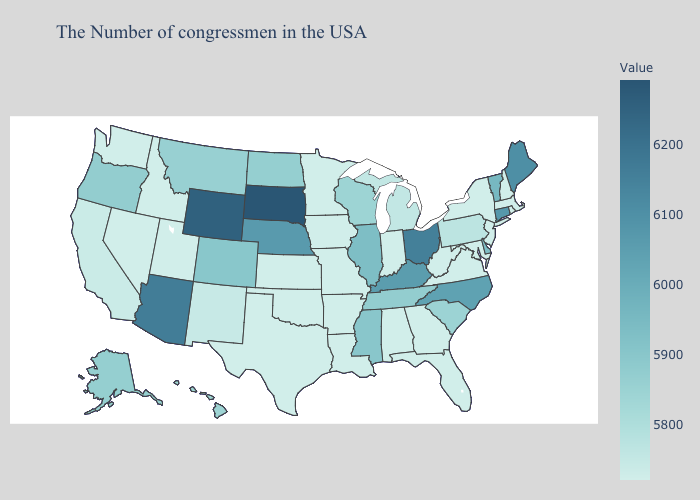Does Nebraska have a lower value than Wisconsin?
Keep it brief. No. Which states have the lowest value in the Northeast?
Concise answer only. Massachusetts, Rhode Island, New Hampshire, New York, New Jersey. Does South Dakota have the highest value in the USA?
Give a very brief answer. Yes. Is the legend a continuous bar?
Keep it brief. Yes. Does South Dakota have the highest value in the USA?
Quick response, please. Yes. Does South Carolina have the lowest value in the USA?
Write a very short answer. No. Is the legend a continuous bar?
Be succinct. Yes. Which states have the highest value in the USA?
Write a very short answer. South Dakota. Is the legend a continuous bar?
Be succinct. Yes. Among the states that border Montana , which have the highest value?
Keep it brief. South Dakota. Among the states that border Alabama , does Florida have the lowest value?
Give a very brief answer. Yes. 